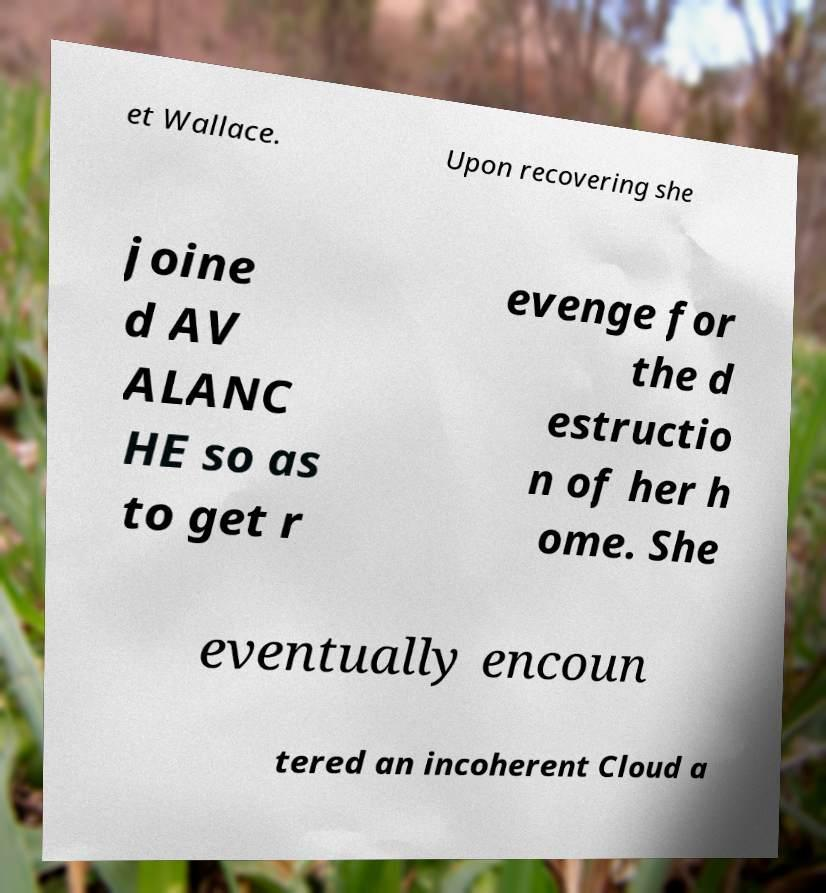I need the written content from this picture converted into text. Can you do that? et Wallace. Upon recovering she joine d AV ALANC HE so as to get r evenge for the d estructio n of her h ome. She eventually encoun tered an incoherent Cloud a 